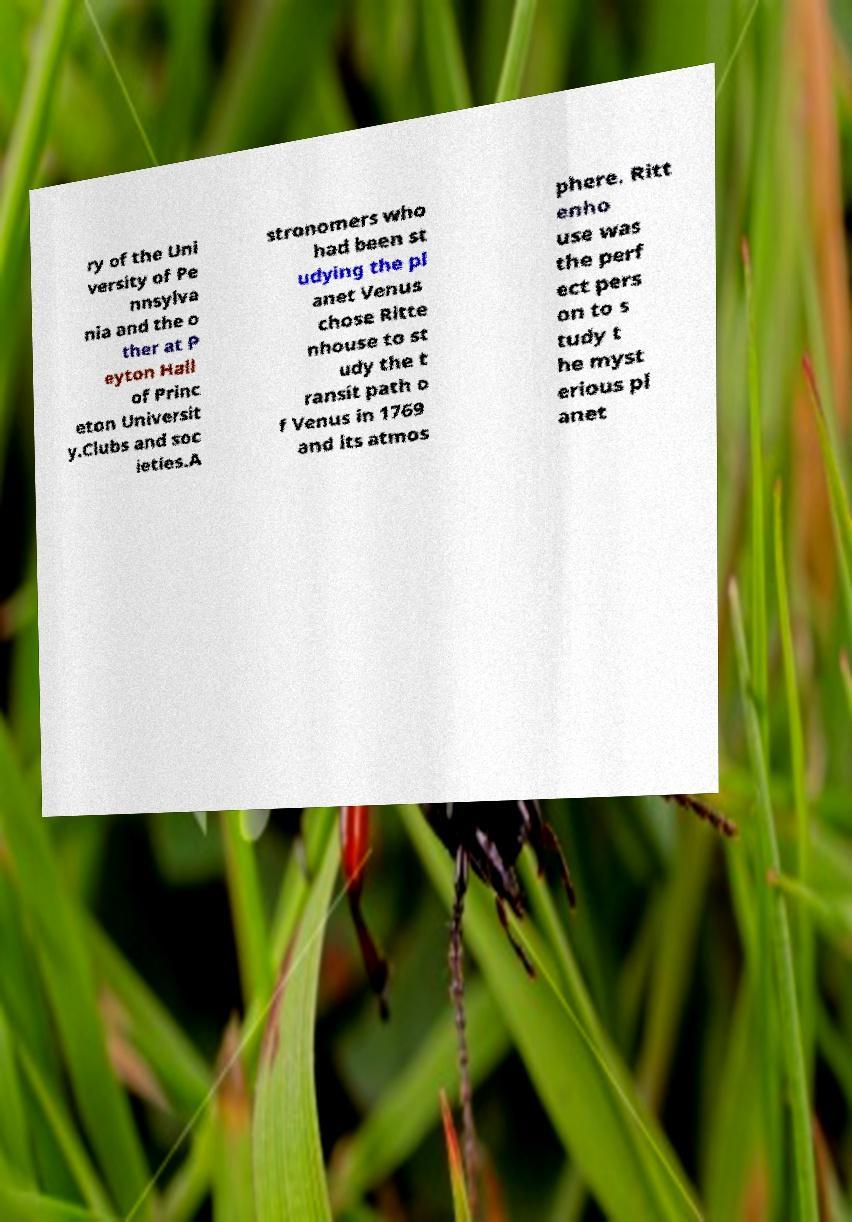Can you accurately transcribe the text from the provided image for me? ry of the Uni versity of Pe nnsylva nia and the o ther at P eyton Hall of Princ eton Universit y.Clubs and soc ieties.A stronomers who had been st udying the pl anet Venus chose Ritte nhouse to st udy the t ransit path o f Venus in 1769 and its atmos phere. Ritt enho use was the perf ect pers on to s tudy t he myst erious pl anet 